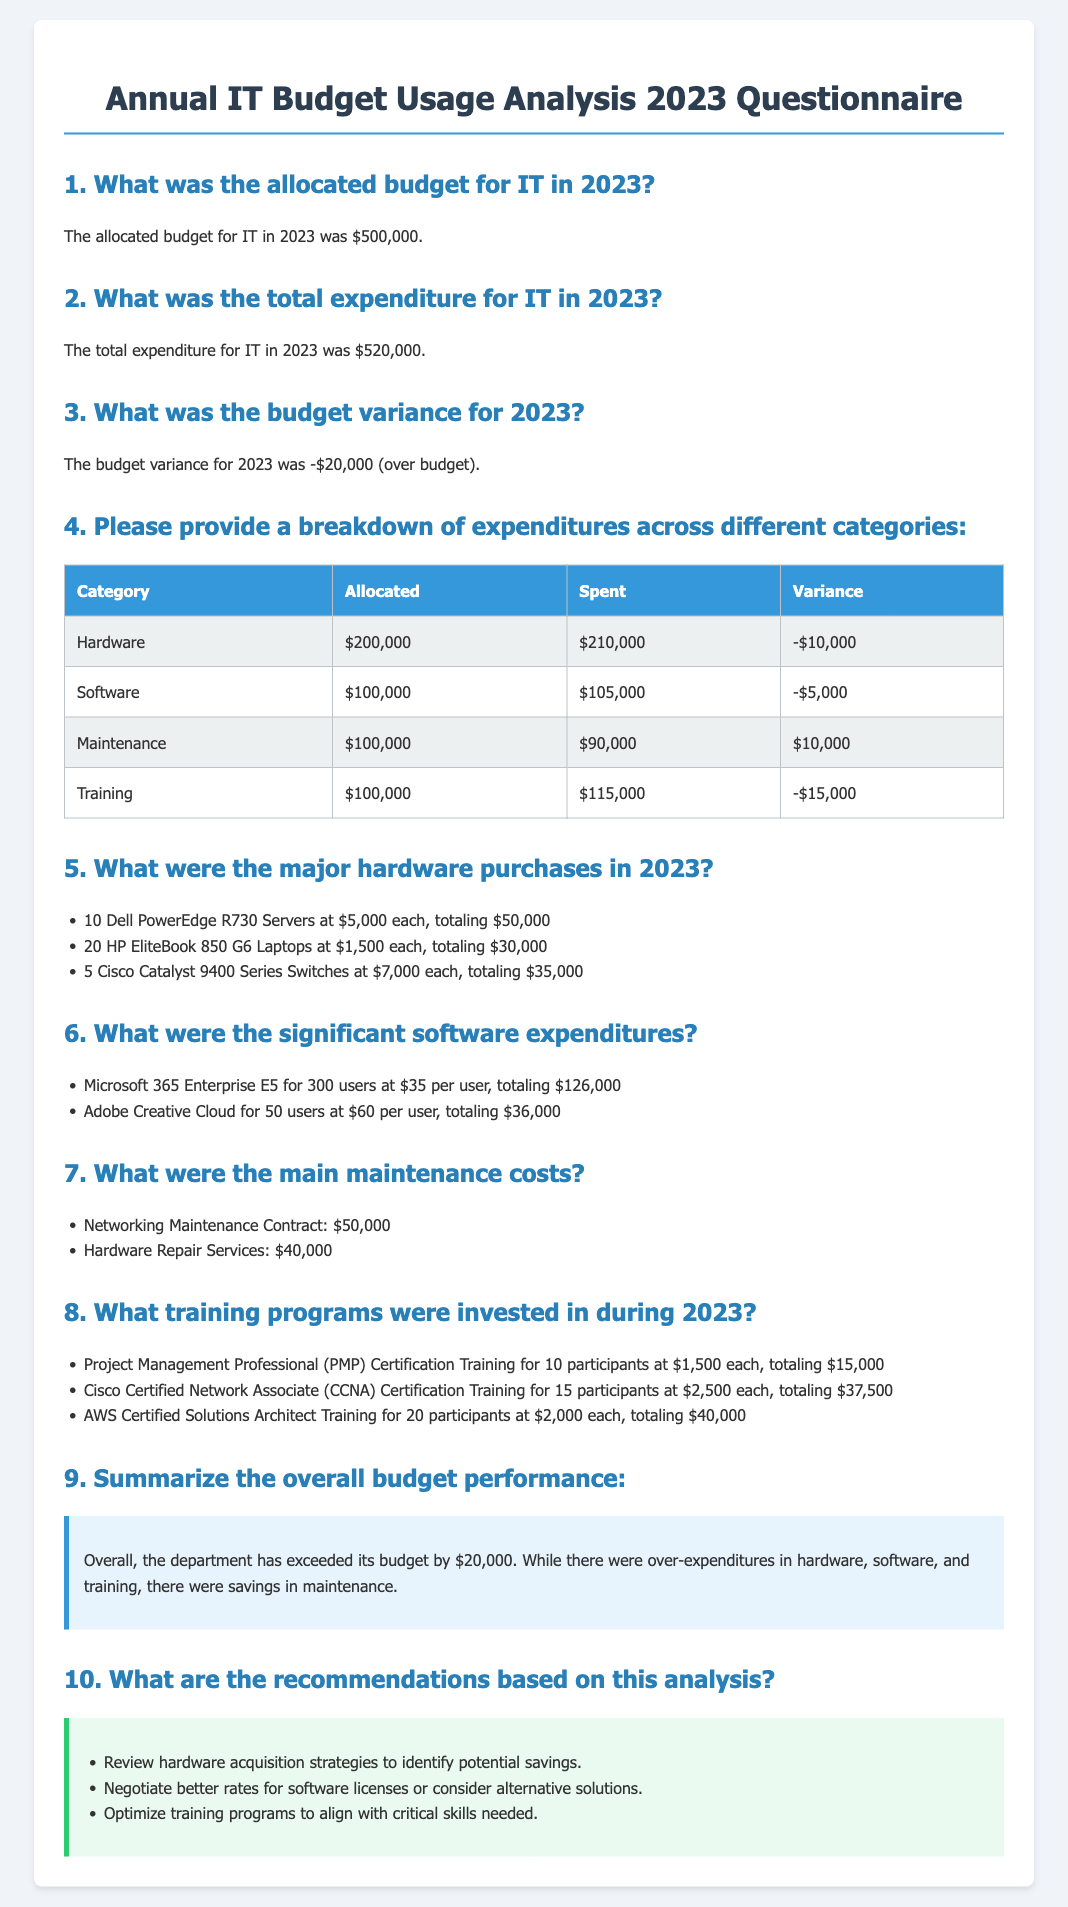What was the allocated budget for IT in 2023? The allocated budget for IT is clearly stated in the document as $500,000.
Answer: $500,000 What were the total expenditures for IT in 2023? The total expenditures for IT are mentioned directly in the document, which is $520,000.
Answer: $520,000 What was the budget variance for 2023? The document provides the budget variance specifically as -$20,000, indicating it was over budget.
Answer: -$20,000 How much was spent on hardware? The expenditure on hardware is detailed in the breakdown table, which shows $210,000 spent.
Answer: $210,000 What were the major hardware purchases? The document lists specific major hardware purchases, including servers and laptops, along with their costs.
Answer: 10 Dell PowerEdge R730 Servers, 20 HP EliteBook 850 G6 Laptops, 5 Cisco Catalyst 9400 Series Switches What was the expenditure on training? The total amount spent on training programs is specified in the breakdown, which states $115,000 spent.
Answer: $115,000 Which category had a surplus? In the breakdown table, maintenance is the only category that shows a surplus, indicating it was under budget.
Answer: Maintenance What recommendations were made based on the analysis? The document includes a section of recommendations that gives three specific suggestions for budget optimization.
Answer: Review hardware acquisition strategies, negotiate better rates for software licenses, optimize training programs What was the total spending on software? The total expenditure on software can be found in the breakdown, where it states $105,000 was spent.
Answer: $105,000 What type of document is this? This document is categorized as a questionnaire specifically analyzing the annual IT budget usage for the year 2023.
Answer: Questionnaire 